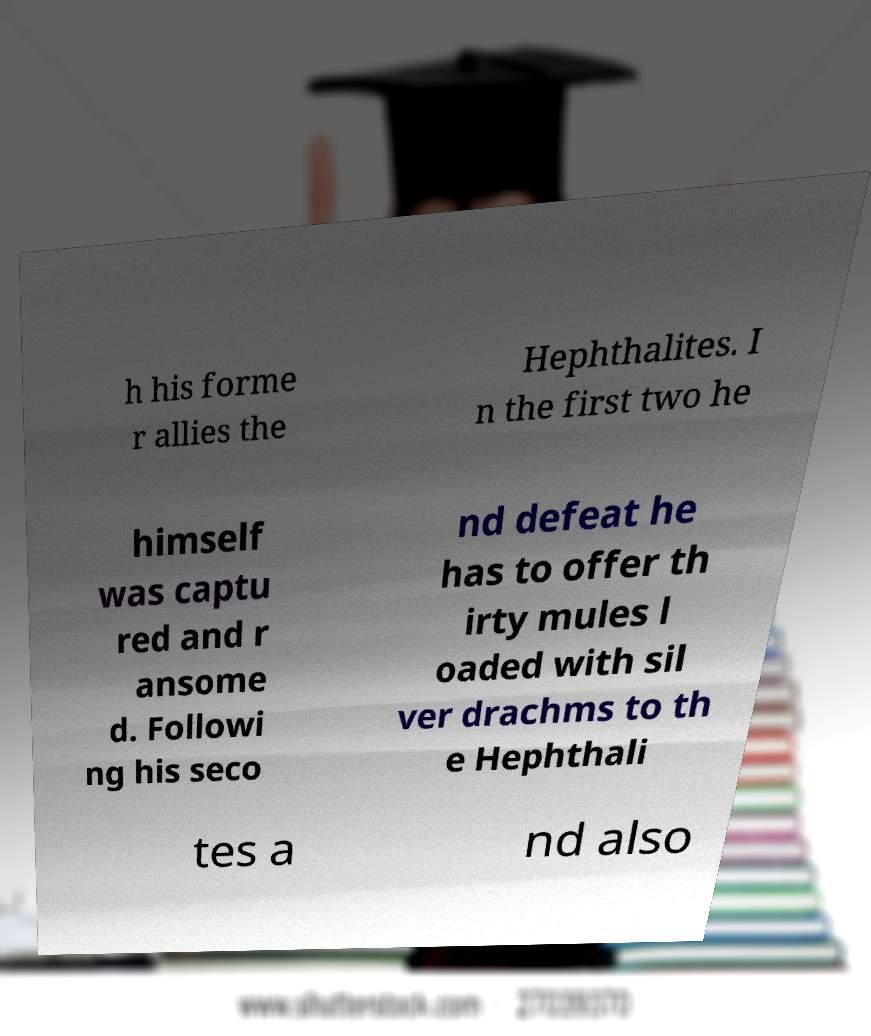Could you assist in decoding the text presented in this image and type it out clearly? h his forme r allies the Hephthalites. I n the first two he himself was captu red and r ansome d. Followi ng his seco nd defeat he has to offer th irty mules l oaded with sil ver drachms to th e Hephthali tes a nd also 